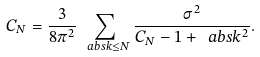<formula> <loc_0><loc_0><loc_500><loc_500>C _ { N } = \frac { 3 } { 8 \pi ^ { 2 } } \sum _ { \ a b s { k } \leq N } \frac { \sigma ^ { 2 } } { C _ { N } - 1 + \ a b s { k } ^ { 2 } } .</formula> 